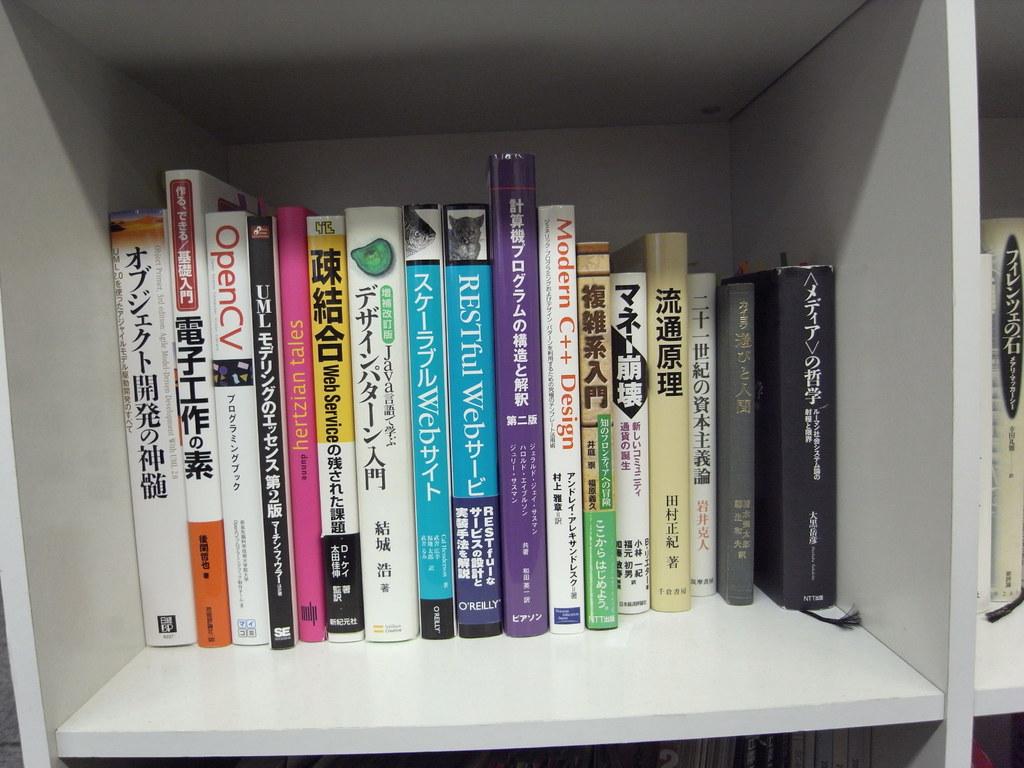What kind of cv is on the third book?
Make the answer very short. Open. Who wrote the 9th book from the left?
Offer a very short reply. Unanswerable. 